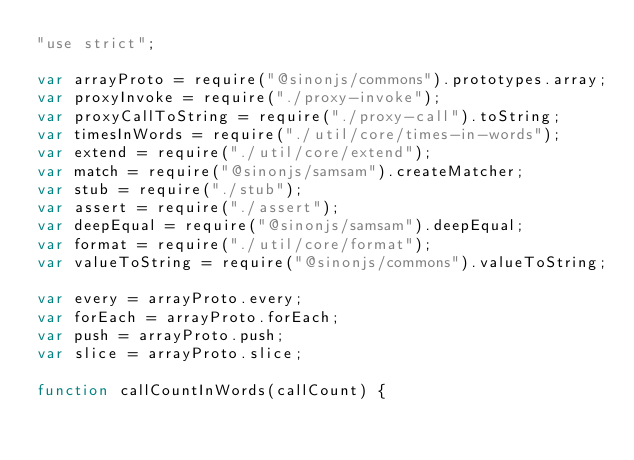<code> <loc_0><loc_0><loc_500><loc_500><_JavaScript_>"use strict";

var arrayProto = require("@sinonjs/commons").prototypes.array;
var proxyInvoke = require("./proxy-invoke");
var proxyCallToString = require("./proxy-call").toString;
var timesInWords = require("./util/core/times-in-words");
var extend = require("./util/core/extend");
var match = require("@sinonjs/samsam").createMatcher;
var stub = require("./stub");
var assert = require("./assert");
var deepEqual = require("@sinonjs/samsam").deepEqual;
var format = require("./util/core/format");
var valueToString = require("@sinonjs/commons").valueToString;

var every = arrayProto.every;
var forEach = arrayProto.forEach;
var push = arrayProto.push;
var slice = arrayProto.slice;

function callCountInWords(callCount) {</code> 